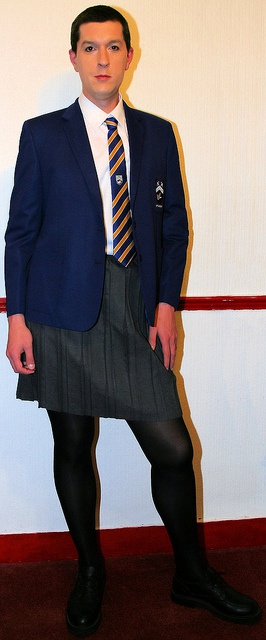Describe the objects in this image and their specific colors. I can see people in tan, black, navy, lightgray, and salmon tones and tie in tan, black, navy, and red tones in this image. 